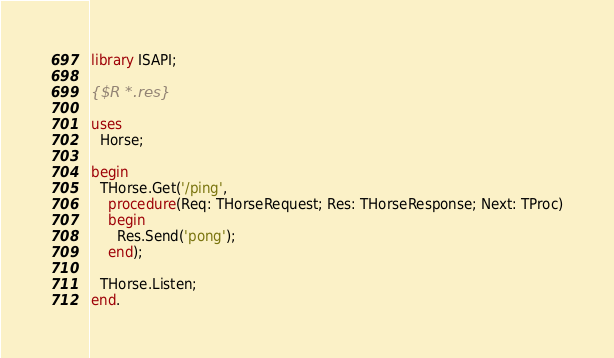Convert code to text. <code><loc_0><loc_0><loc_500><loc_500><_Pascal_>library ISAPI;

{$R *.res}

uses
  Horse;

begin
  THorse.Get('/ping',
    procedure(Req: THorseRequest; Res: THorseResponse; Next: TProc)
    begin
      Res.Send('pong');
    end);

  THorse.Listen;
end.
</code> 